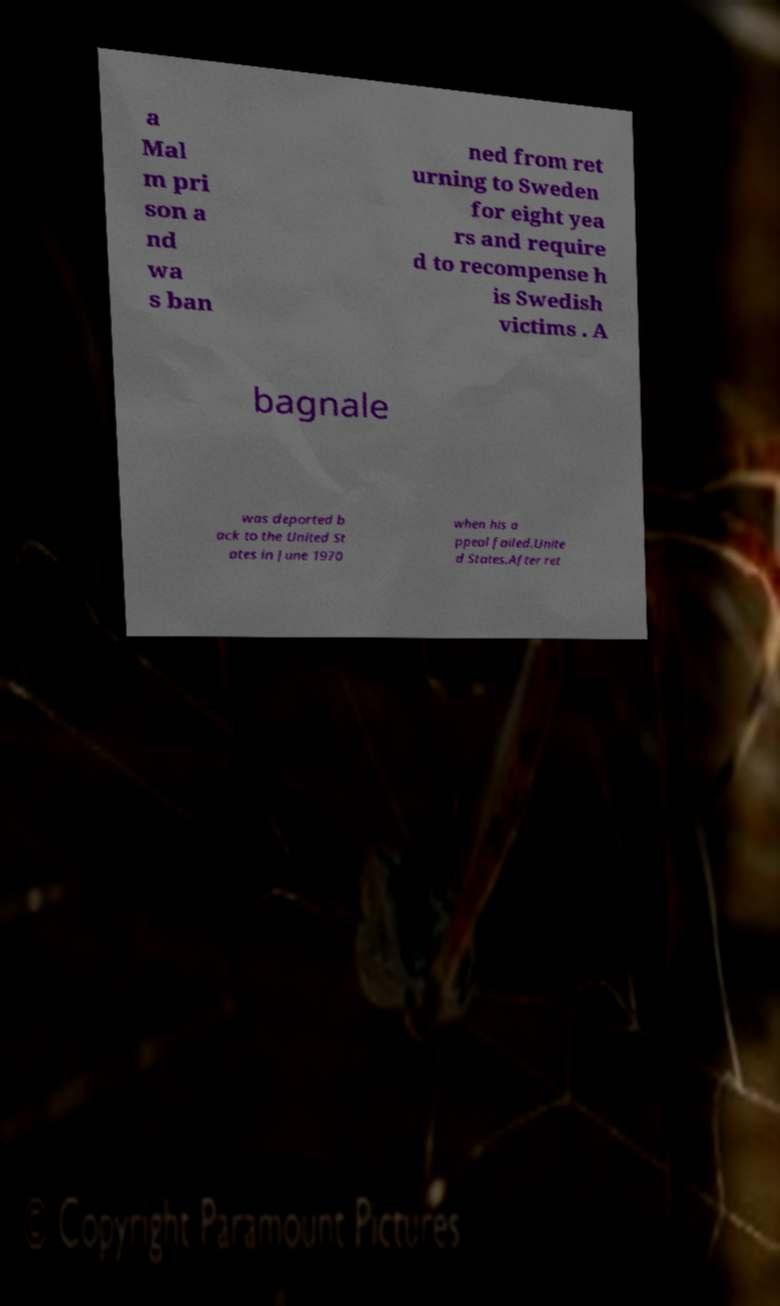Please read and relay the text visible in this image. What does it say? a Mal m pri son a nd wa s ban ned from ret urning to Sweden for eight yea rs and require d to recompense h is Swedish victims . A bagnale was deported b ack to the United St ates in June 1970 when his a ppeal failed.Unite d States.After ret 